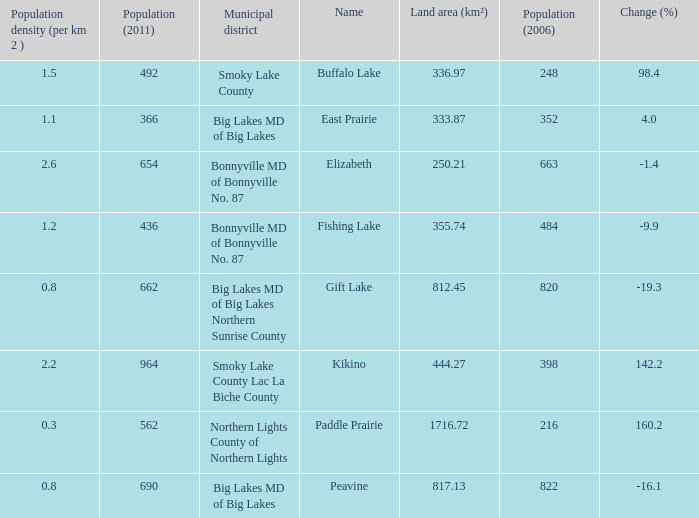What place is there a change of -19.3? 1.0. 